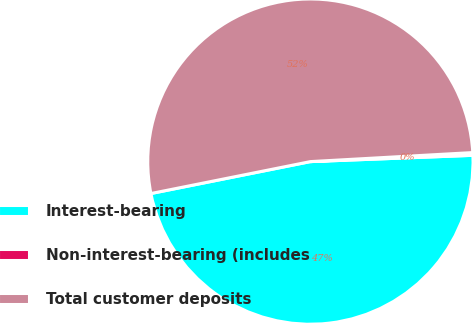Convert chart. <chart><loc_0><loc_0><loc_500><loc_500><pie_chart><fcel>Interest-bearing<fcel>Non-interest-bearing (includes<fcel>Total customer deposits<nl><fcel>47.47%<fcel>0.27%<fcel>52.26%<nl></chart> 